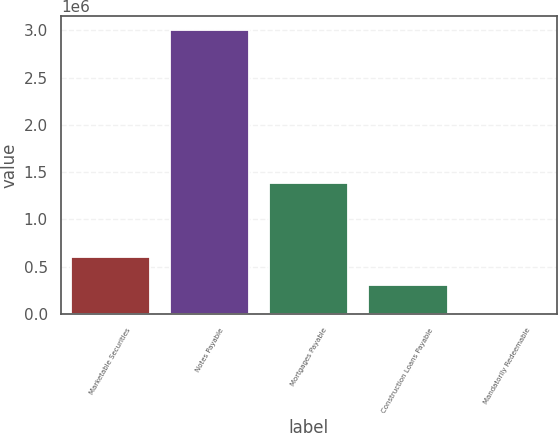Convert chart. <chart><loc_0><loc_0><loc_500><loc_500><bar_chart><fcel>Marketable Securities<fcel>Notes Payable<fcel>Mortgages Payable<fcel>Construction Loans Payable<fcel>Mandatorily Redeemable<nl><fcel>602275<fcel>3.0003e+06<fcel>1.38826e+06<fcel>302522<fcel>2768<nl></chart> 